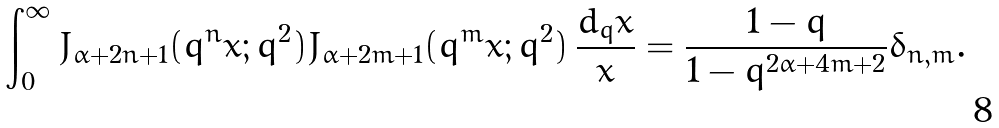Convert formula to latex. <formula><loc_0><loc_0><loc_500><loc_500>\int _ { 0 } ^ { \infty } J _ { \alpha + 2 n + 1 } ( q ^ { n } x ; q ^ { 2 } ) J _ { \alpha + 2 m + 1 } ( q ^ { m } x ; q ^ { 2 } ) \, \frac { d _ { q } x } { x } = \frac { 1 - q } { 1 - q ^ { 2 \alpha + 4 m + 2 } } \delta _ { n , m } .</formula> 